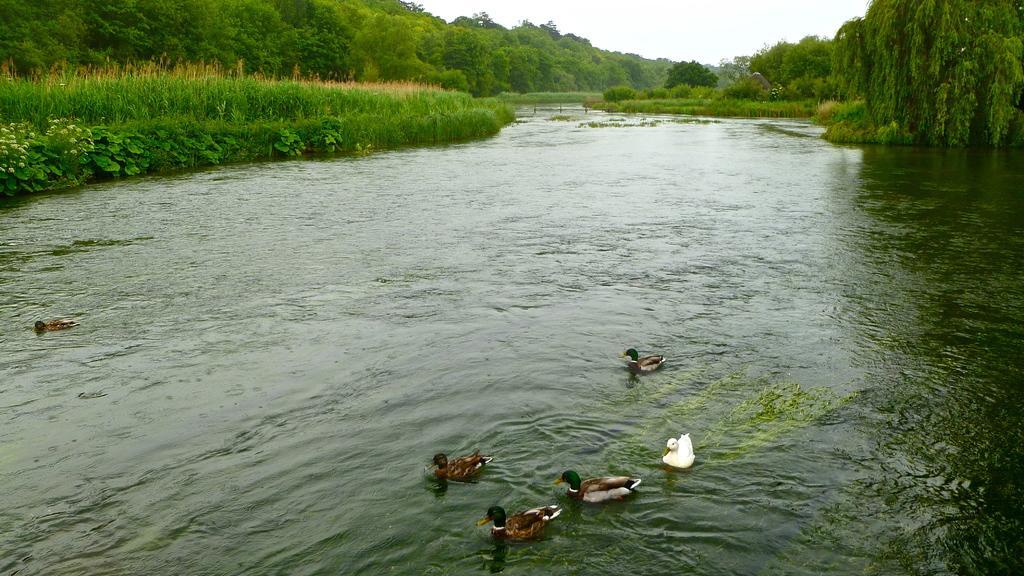Can you describe this image briefly? In this image we can see the birds on the surface of the water. We can also see many trees and also the grass. Sky is also also visible. 